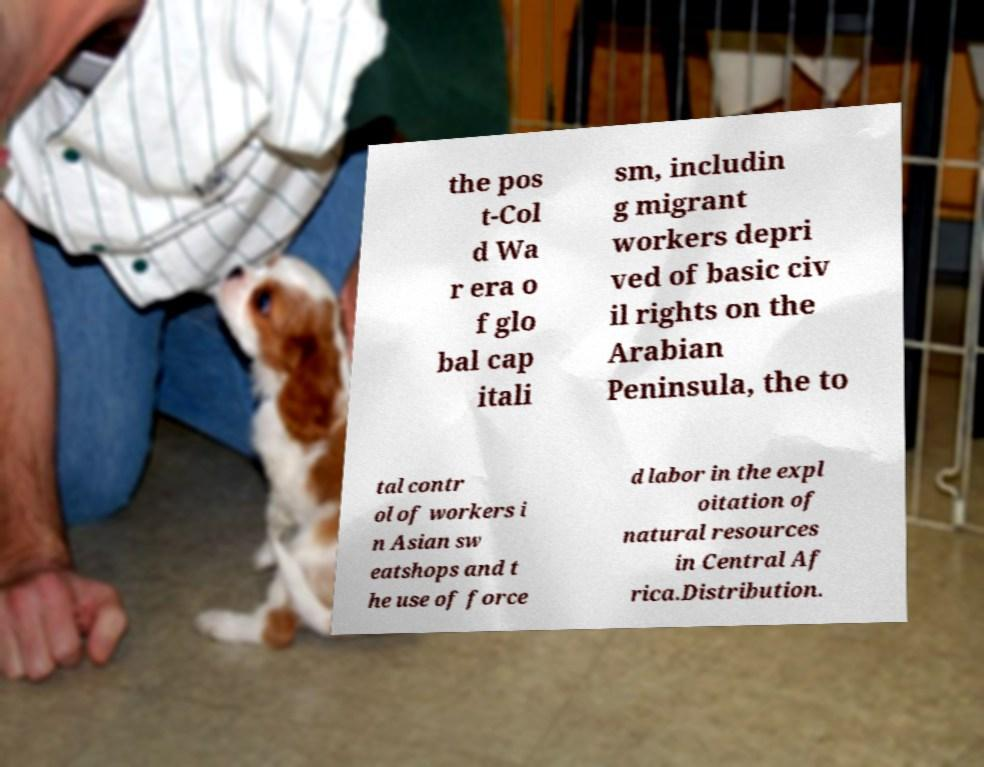Please read and relay the text visible in this image. What does it say? the pos t-Col d Wa r era o f glo bal cap itali sm, includin g migrant workers depri ved of basic civ il rights on the Arabian Peninsula, the to tal contr ol of workers i n Asian sw eatshops and t he use of force d labor in the expl oitation of natural resources in Central Af rica.Distribution. 